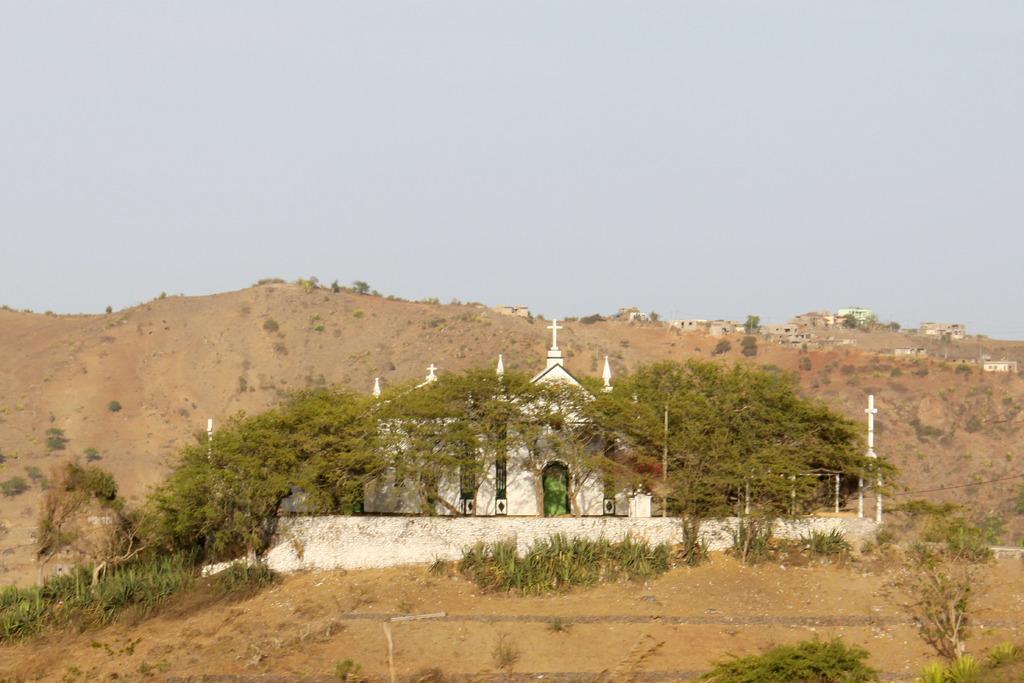Describe this image in one or two sentences. In this image I can see the ground, few plants, few trees which are green in color and a building which is white in color. I can see a mountain and few buildings on the mountain. In the background I can see the sky. 